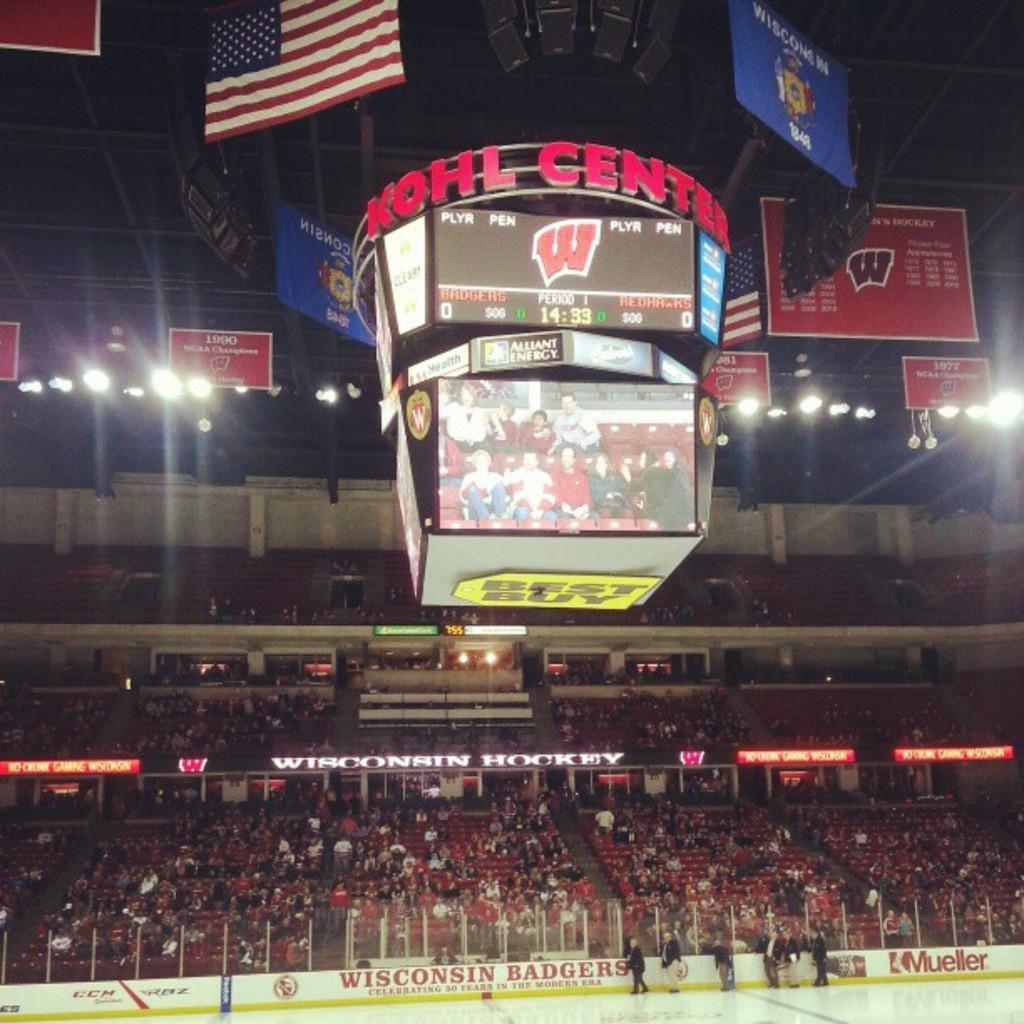<image>
Write a terse but informative summary of the picture. a Wiscon Badgers advertisement at the Kohl Center. 